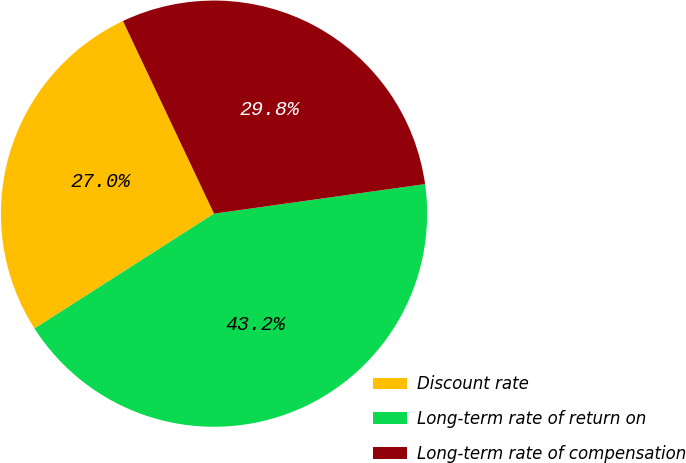<chart> <loc_0><loc_0><loc_500><loc_500><pie_chart><fcel>Discount rate<fcel>Long-term rate of return on<fcel>Long-term rate of compensation<nl><fcel>27.03%<fcel>43.16%<fcel>29.81%<nl></chart> 